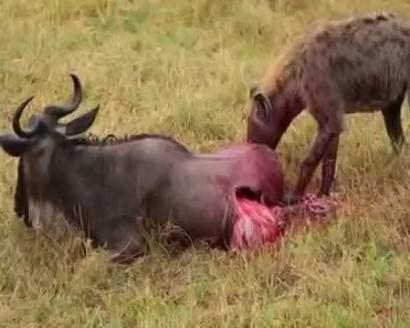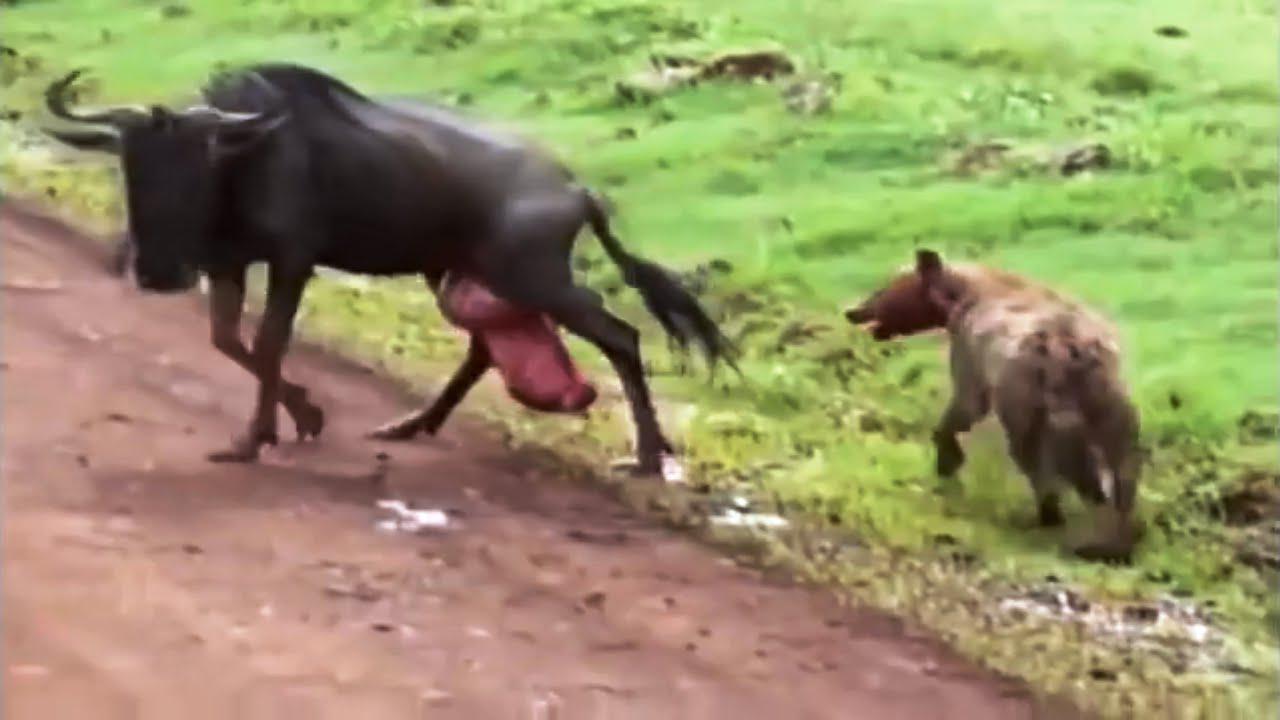The first image is the image on the left, the second image is the image on the right. Evaluate the accuracy of this statement regarding the images: "There is no more than one hyena in the right image.". Is it true? Answer yes or no. Yes. The first image is the image on the left, the second image is the image on the right. For the images displayed, is the sentence "The target of the hyenas appears to still be alive in both images." factually correct? Answer yes or no. Yes. 